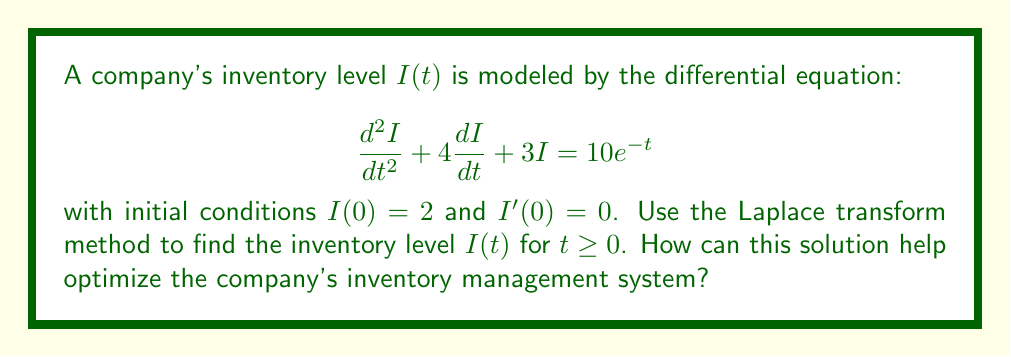Solve this math problem. Let's solve this problem step by step using the Laplace transform method:

1) First, we take the Laplace transform of both sides of the equation:

   $$\mathcal{L}\left\{\frac{d^2I}{dt^2} + 4\frac{dI}{dt} + 3I\right\} = \mathcal{L}\{10e^{-t}\}$$

2) Using Laplace transform properties:

   $$s^2I(s) - sI(0) - I'(0) + 4[sI(s) - I(0)] + 3I(s) = \frac{10}{s+1}$$

3) Substituting the initial conditions $I(0) = 2$ and $I'(0) = 0$:

   $$s^2I(s) - 2s + 4sI(s) - 8 + 3I(s) = \frac{10}{s+1}$$

4) Simplifying:

   $$(s^2 + 4s + 3)I(s) = \frac{10}{s+1} + 2s + 8$$

5) Solving for $I(s)$:

   $$I(s) = \frac{10}{(s+1)(s^2 + 4s + 3)} + \frac{2s + 8}{s^2 + 4s + 3}$$

6) Decomposing into partial fractions:

   $$I(s) = \frac{A}{s+1} + \frac{B}{s+1} + \frac{C}{s+3} + \frac{2s + 8}{s^2 + 4s + 3}$$

7) Solving for $A$, $B$, and $C$:

   $$A = 1, B = 1, C = -2$$

8) Taking the inverse Laplace transform:

   $$I(t) = e^{-t} + e^{-t} - 2e^{-3t} + 2e^{-t} - 2te^{-2t}$$

9) Simplifying:

   $$I(t) = 4e^{-t} - 2e^{-3t} - 2te^{-2t}$$

This solution can help optimize the company's inventory management system by:

1. Predicting future inventory levels based on current trends.
2. Identifying potential stockouts or overstock situations.
3. Adjusting ordering and production schedules to maintain optimal inventory levels.
4. Minimizing carrying costs while ensuring sufficient stock to meet demand.
5. Analyzing the impact of different factors (represented by the terms in the equation) on inventory fluctuations.
Answer: The inventory level $I(t)$ for $t \geq 0$ is:

$$I(t) = 4e^{-t} - 2e^{-3t} - 2te^{-2t}$$

This solution can optimize inventory management by enabling accurate forecasting, preventing stockouts and overstocking, adjusting schedules, minimizing costs, and analyzing inventory fluctuation factors. 